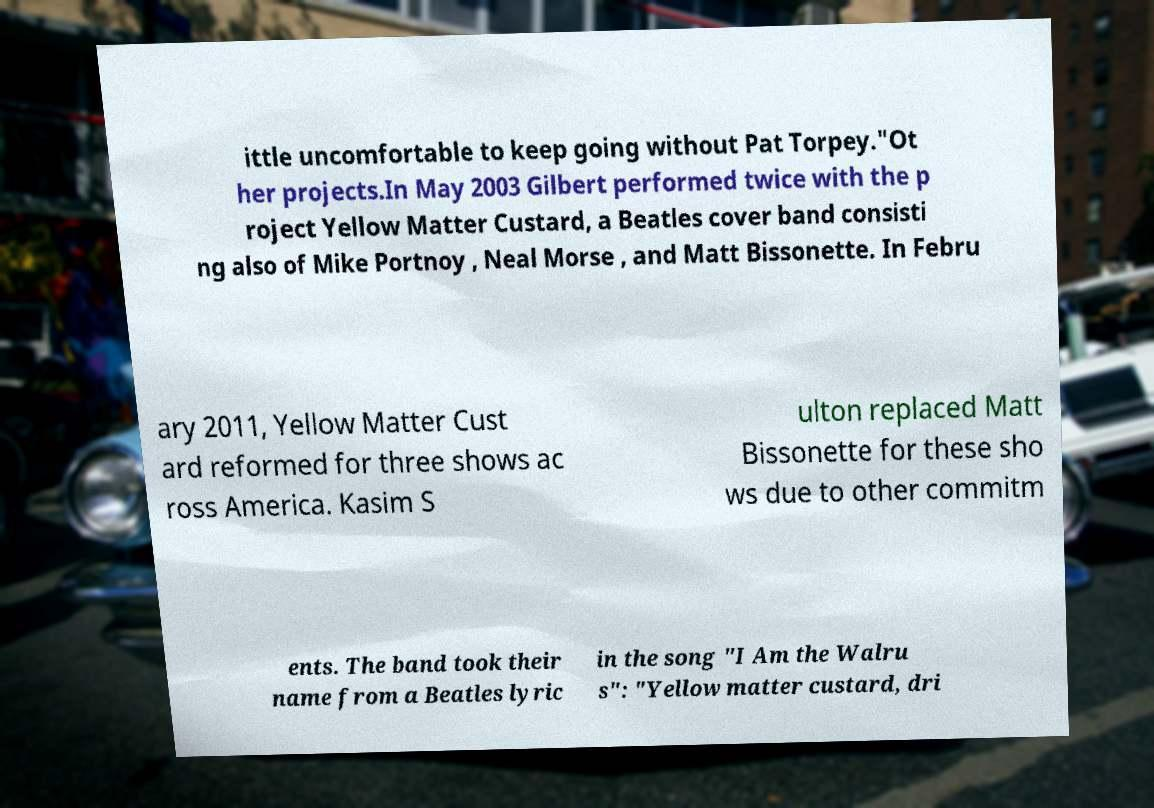There's text embedded in this image that I need extracted. Can you transcribe it verbatim? ittle uncomfortable to keep going without Pat Torpey."Ot her projects.In May 2003 Gilbert performed twice with the p roject Yellow Matter Custard, a Beatles cover band consisti ng also of Mike Portnoy , Neal Morse , and Matt Bissonette. In Febru ary 2011, Yellow Matter Cust ard reformed for three shows ac ross America. Kasim S ulton replaced Matt Bissonette for these sho ws due to other commitm ents. The band took their name from a Beatles lyric in the song "I Am the Walru s": "Yellow matter custard, dri 